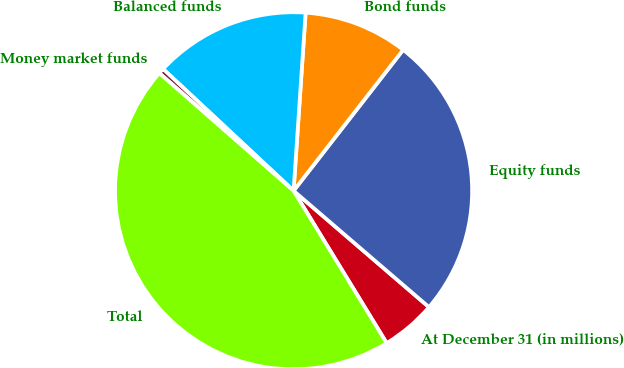Convert chart to OTSL. <chart><loc_0><loc_0><loc_500><loc_500><pie_chart><fcel>At December 31 (in millions)<fcel>Equity funds<fcel>Bond funds<fcel>Balanced funds<fcel>Money market funds<fcel>Total<nl><fcel>4.97%<fcel>25.78%<fcel>9.44%<fcel>14.12%<fcel>0.5%<fcel>45.18%<nl></chart> 